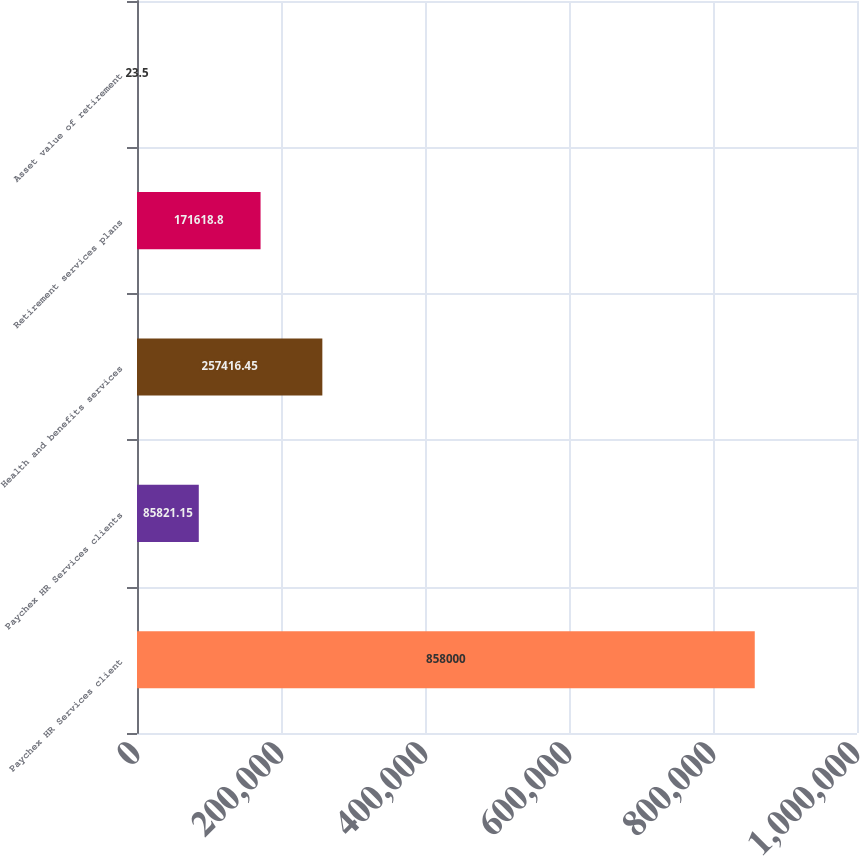<chart> <loc_0><loc_0><loc_500><loc_500><bar_chart><fcel>Paychex HR Services client<fcel>Paychex HR Services clients<fcel>Health and benefits services<fcel>Retirement services plans<fcel>Asset value of retirement<nl><fcel>858000<fcel>85821.1<fcel>257416<fcel>171619<fcel>23.5<nl></chart> 